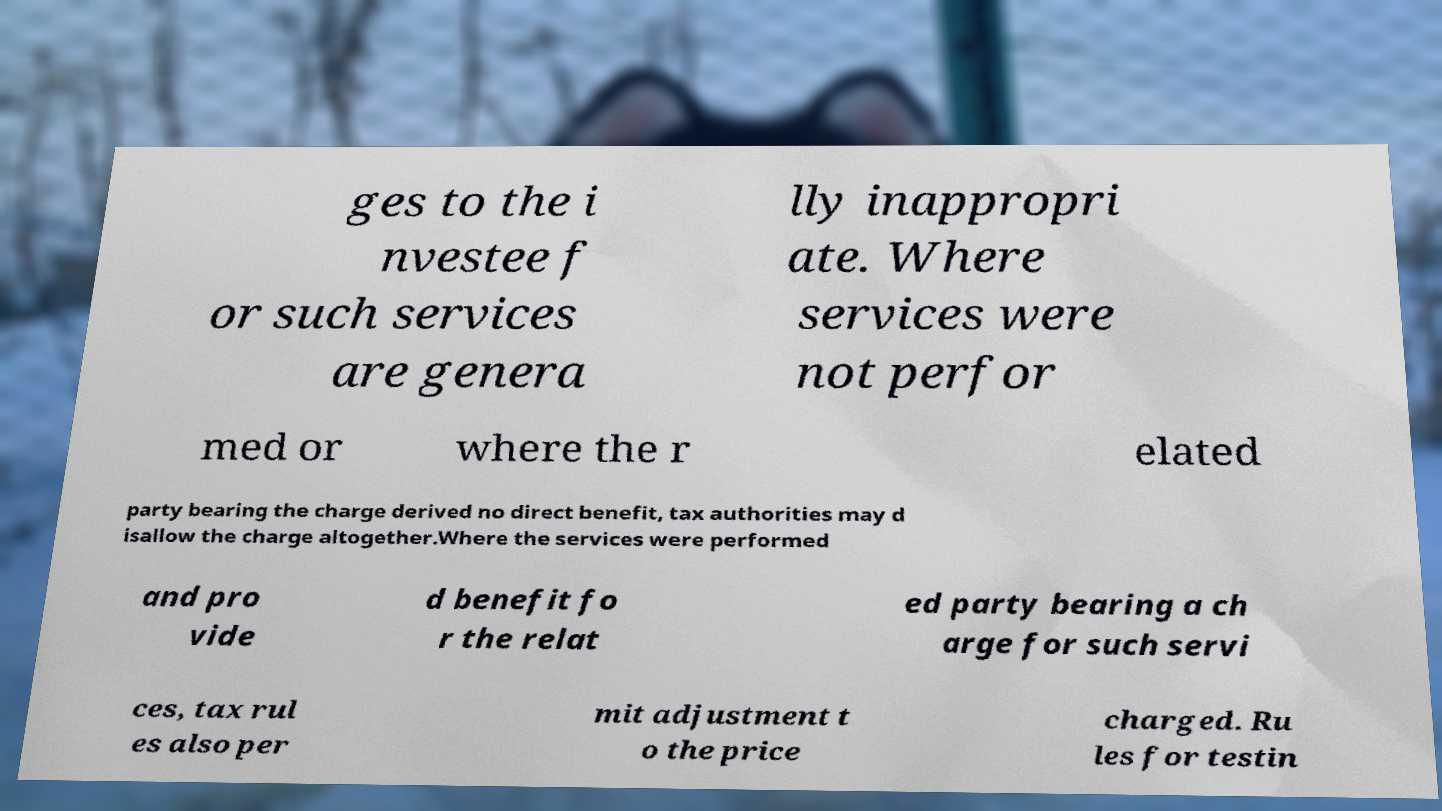Could you extract and type out the text from this image? ges to the i nvestee f or such services are genera lly inappropri ate. Where services were not perfor med or where the r elated party bearing the charge derived no direct benefit, tax authorities may d isallow the charge altogether.Where the services were performed and pro vide d benefit fo r the relat ed party bearing a ch arge for such servi ces, tax rul es also per mit adjustment t o the price charged. Ru les for testin 